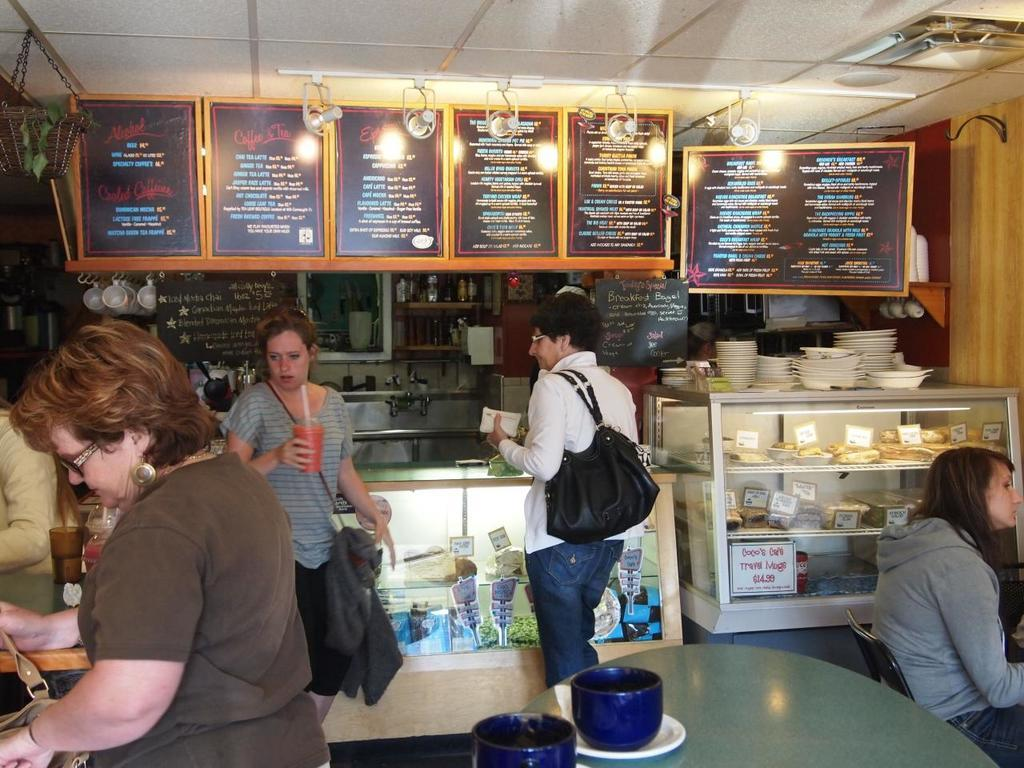What is the primary activity of the people in the image? The people in the image are standing, which suggests they might be waiting or socializing. What is the woman in the image doing? The woman is sitting in the image. Can you describe the location of the image? The setting is a coffee shop. What color is the crayon being used by the woman in the image? There is no crayon present in the image; the woman is sitting, but no specific activity is mentioned. 